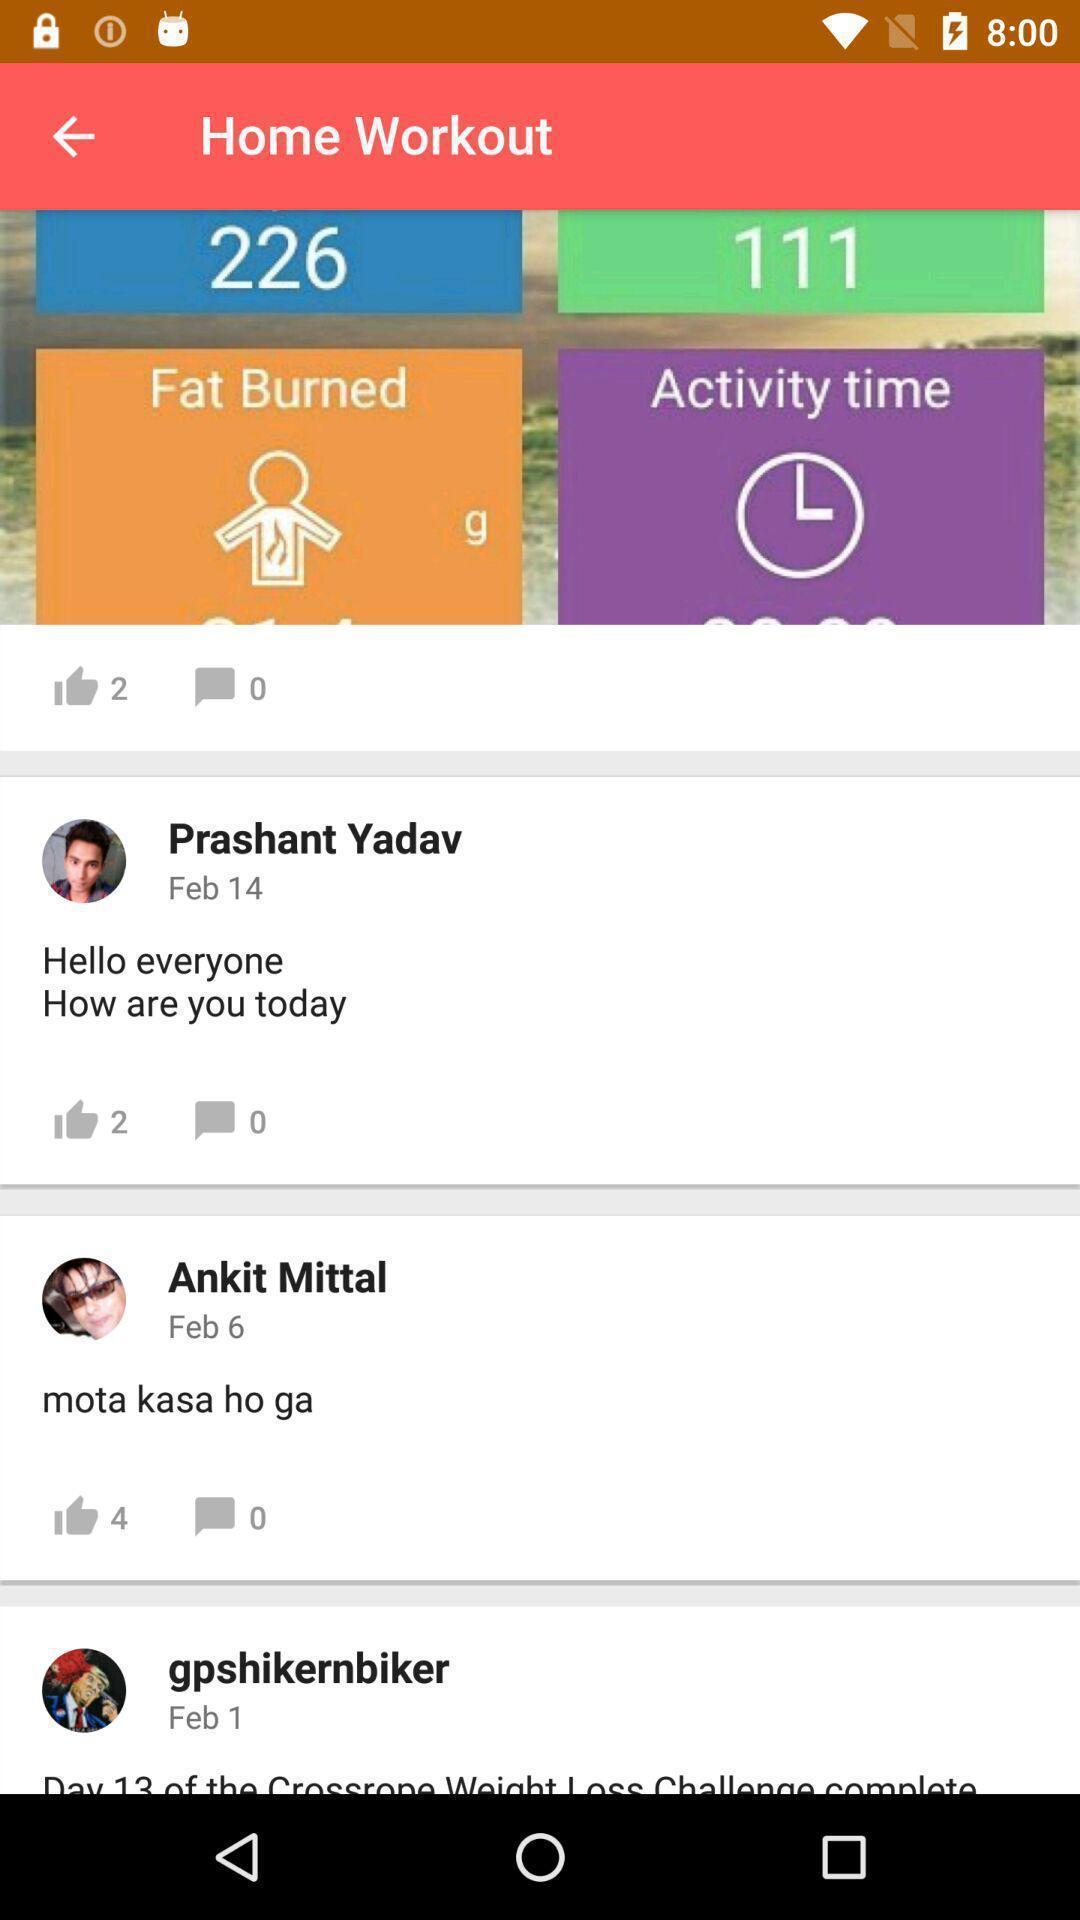Explain what's happening in this screen capture. Various feed displayed of a workout app. 